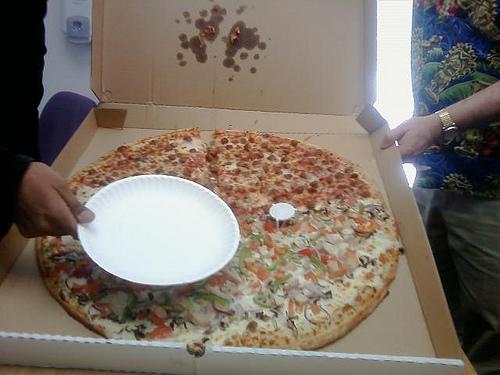How many different types of pizza are on display?
Give a very brief answer. 2. What is in the white cup?
Give a very brief answer. No white cup. What is on the wrist?
Be succinct. Watch. Is there an apple on table?
Be succinct. No. What is the man holding?
Give a very brief answer. Paper plate. How many pieces of pizza are eaten?
Write a very short answer. 0. 